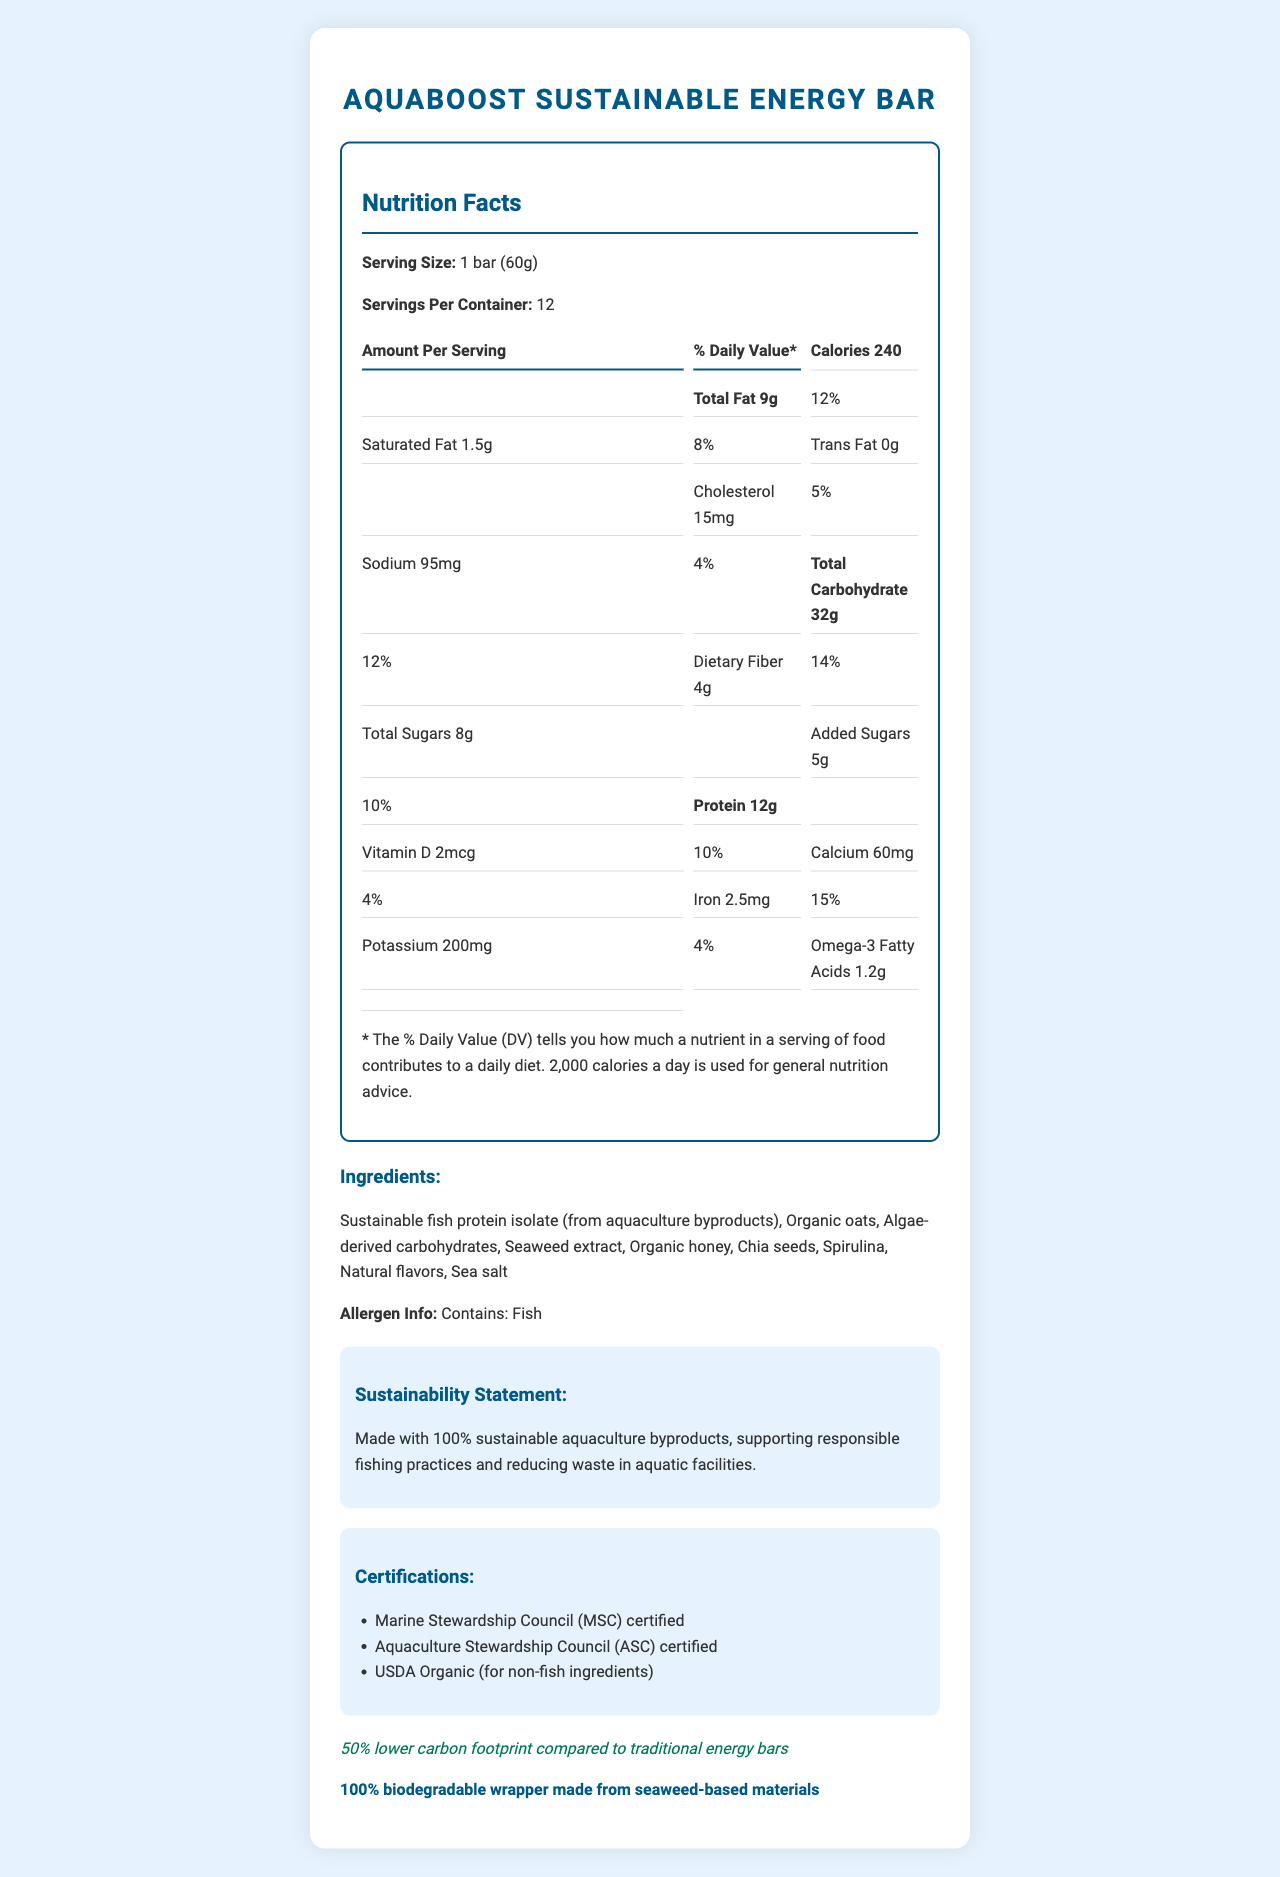what is the serving size for AquaBoost Sustainable Energy Bar? The serving size is clearly mentioned as "1 bar (60g)".
Answer: 1 bar (60g) how many calories are in one serving? The document states that each serving contains 240 calories.
Answer: 240 how much total fat is in one serving? The total fat amount per serving is listed as 9g.
Answer: 9g what is the daily value percentage for dietary fiber? The daily value percentage for dietary fiber is stated as 14%.
Answer: 14% Which certifications does AquaBoost Sustainable Energy Bar hold? A. USDA Organic B. Marine Stewardship Council C. Fair Trade Certified D. Aquaculture Stewardship Council The energy bar is Marine Stewardship Council (MSC) certified and Aquaculture Stewardship Council (ASC) certified.
Answer: B and D What is the main ingredient in AquaBoost Sustainable Energy Bar? A. Organic oats B. Seaweed extract C. Sustainable fish protein isolate D. Chia seeds The first listed ingredient is "Sustainable fish protein isolate (from aquaculture byproducts)," indicating it is the main ingredient.
Answer: C Does AquaBoost Sustainable Energy Bar contain any allergens? The allergen info specifies that the product contains fish.
Answer: Yes Describe the main idea of the document. The document details the nutritional values, ingredients, allergen information, sustainability statements, certifications, environmental impact, and packaging of the AquaBoost Sustainable Energy Bar.
Answer: Summary of the AquaBoost Sustainable Energy Bar's nutrition facts, ingredients, sustainability aspects, and certifications. How much iron is in one serving, and what is its daily value percentage? The amount of iron per serving is 2.5mg and its daily value percentage is 15%.
Answer: 2.5mg, 15% how many total carbohydrates are in one serving? The total carbohydrate amount per serving is listed as 32g.
Answer: 32g What packaging material is used for the AquaBoost Sustainable Energy Bar? The document states that the packaging is made from 100% biodegradable wrapper made from seaweed-based materials.
Answer: seaweed-based materials Is there any trans fat in the AquaBoost Sustainable Energy Bar? It is specified that the trans fat content is 0g.
Answer: No What is the amount of added sugars per serving? The amount of added sugars per serving is 5g.
Answer: 5g What is the environmental impact of the AquaBoost Energy Bar compared to traditional energy bars? The document states that the product has a 50% lower carbon footprint compared to traditional energy bars.
Answer: 50% lower carbon footprint What vitamins and minerals are included in the nutrition facts, and what are their daily value percentages? The document provides the daily value percentages for Vitamin D (10%), Calcium (4%), Iron (15%), and Potassium (4%).
Answer: Vitamin D: 10%, Calcium: 4%, Iron: 15%, Potassium: 4% Does the document provide any information on the production cost of the AquaBoost Sustainable Energy Bar? The document does not provide any information regarding the production cost.
Answer: Not enough information Does the AquaBoost Sustainable Energy Bar support sustainability in its production? The sustainability statement claims the product is made with 100% sustainable aquaculture byproducts, supporting responsible fishing practices and reducing waste.
Answer: Yes 